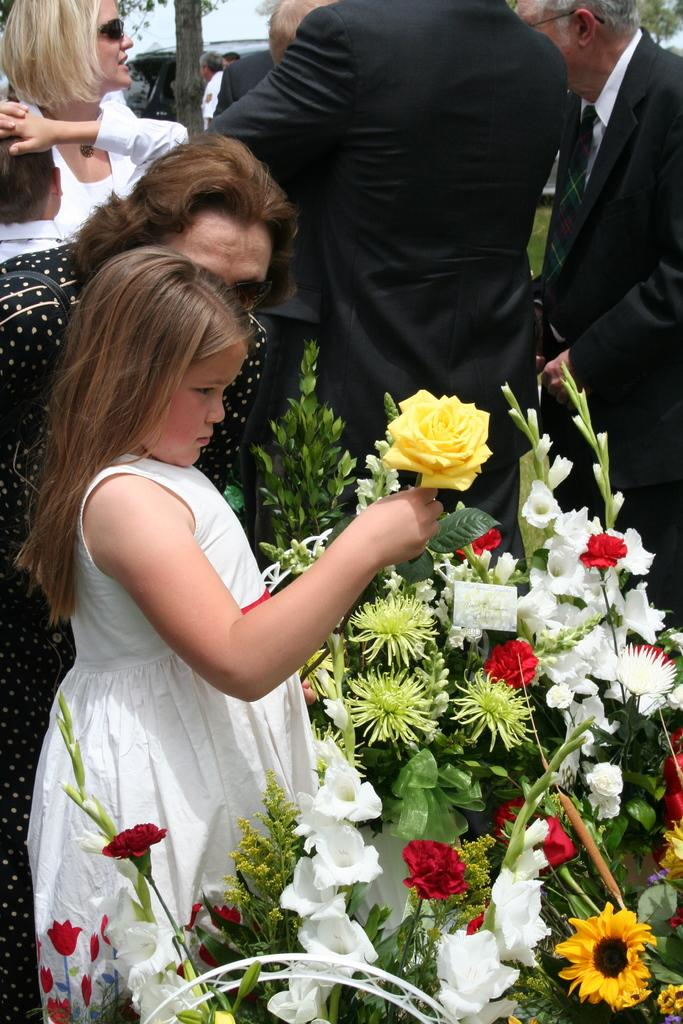Who is the main subject on the left side of the image? There is a little girl standing on the left side of the image. What is the girl wearing? The girl is wearing a white dress. What can be seen on the right side of the image? There are flowers on the right side of the image. Who else is present in the image besides the little girl? There are men standing in the image. What are the men wearing? The men are wearing white dresses. What type of sack can be seen on the wrist of the little girl in the image? There is no sack visible on the wrist of the little girl in the image. What authority figure is present in the image? There is no specific authority figure mentioned or depicted in the image. 